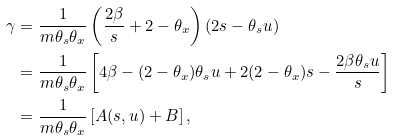Convert formula to latex. <formula><loc_0><loc_0><loc_500><loc_500>\gamma & = \frac { 1 } { m \theta _ { s } \theta _ { x } } \left ( \frac { 2 \beta } { s } + 2 - \theta _ { x } \right ) ( 2 s - \theta _ { s } u ) \\ & = \frac { 1 } { m \theta _ { s } \theta _ { x } } \left [ 4 \beta - ( 2 - \theta _ { x } ) \theta _ { s } u + 2 ( 2 - \theta _ { x } ) s - \frac { 2 \beta \theta _ { s } u } { s } \right ] \\ & = \frac { 1 } { m \theta _ { s } \theta _ { x } } \left [ A ( s , u ) + B \right ] ,</formula> 